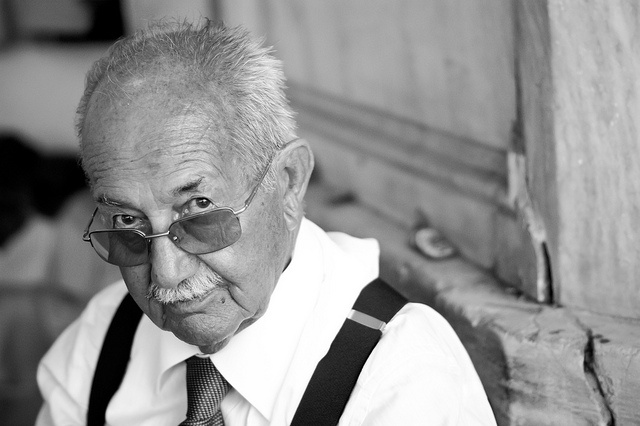Describe the objects in this image and their specific colors. I can see people in black, white, darkgray, and gray tones and tie in black, gray, darkgray, and lightgray tones in this image. 